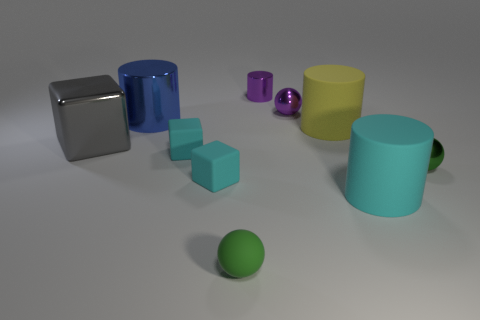How many green balls must be subtracted to get 1 green balls? 1 Subtract all small shiny balls. How many balls are left? 1 Subtract all purple spheres. How many spheres are left? 2 Subtract all cylinders. How many objects are left? 6 Subtract 2 balls. How many balls are left? 1 Subtract all cyan cylinders. How many gray cubes are left? 1 Subtract all big gray metallic things. Subtract all gray things. How many objects are left? 8 Add 5 cyan rubber blocks. How many cyan rubber blocks are left? 7 Add 5 small cyan blocks. How many small cyan blocks exist? 7 Subtract 0 gray balls. How many objects are left? 10 